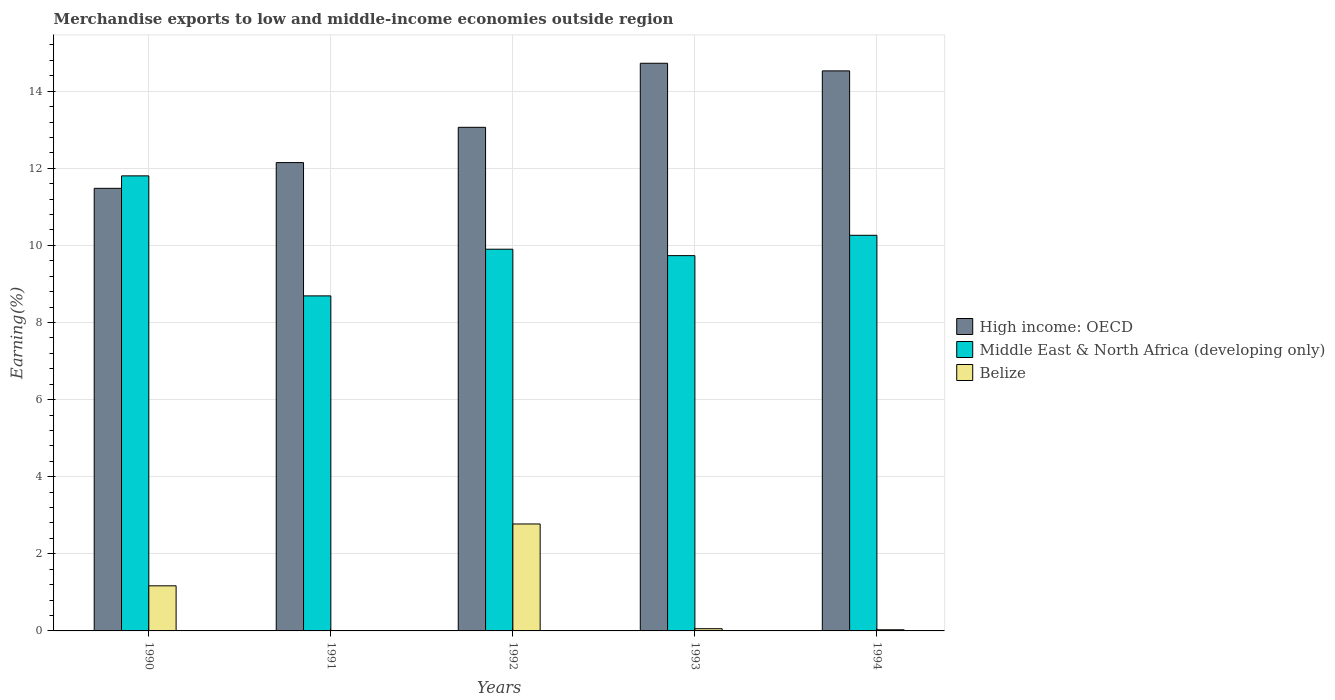How many groups of bars are there?
Your response must be concise. 5. Are the number of bars per tick equal to the number of legend labels?
Provide a short and direct response. Yes. How many bars are there on the 3rd tick from the left?
Offer a very short reply. 3. How many bars are there on the 3rd tick from the right?
Offer a very short reply. 3. What is the label of the 4th group of bars from the left?
Provide a short and direct response. 1993. In how many cases, is the number of bars for a given year not equal to the number of legend labels?
Offer a very short reply. 0. What is the percentage of amount earned from merchandise exports in Belize in 1990?
Your response must be concise. 1.17. Across all years, what is the maximum percentage of amount earned from merchandise exports in Middle East & North Africa (developing only)?
Provide a short and direct response. 11.8. Across all years, what is the minimum percentage of amount earned from merchandise exports in Belize?
Your answer should be very brief. 0. In which year was the percentage of amount earned from merchandise exports in High income: OECD maximum?
Offer a very short reply. 1993. What is the total percentage of amount earned from merchandise exports in High income: OECD in the graph?
Offer a terse response. 65.94. What is the difference between the percentage of amount earned from merchandise exports in Belize in 1990 and that in 1993?
Keep it short and to the point. 1.11. What is the difference between the percentage of amount earned from merchandise exports in Middle East & North Africa (developing only) in 1994 and the percentage of amount earned from merchandise exports in High income: OECD in 1990?
Keep it short and to the point. -1.22. What is the average percentage of amount earned from merchandise exports in Belize per year?
Ensure brevity in your answer.  0.81. In the year 1991, what is the difference between the percentage of amount earned from merchandise exports in Middle East & North Africa (developing only) and percentage of amount earned from merchandise exports in Belize?
Provide a short and direct response. 8.69. In how many years, is the percentage of amount earned from merchandise exports in Middle East & North Africa (developing only) greater than 11.2 %?
Give a very brief answer. 1. What is the ratio of the percentage of amount earned from merchandise exports in Belize in 1990 to that in 1994?
Provide a succinct answer. 39.32. Is the percentage of amount earned from merchandise exports in Belize in 1993 less than that in 1994?
Keep it short and to the point. No. What is the difference between the highest and the second highest percentage of amount earned from merchandise exports in Belize?
Keep it short and to the point. 1.6. What is the difference between the highest and the lowest percentage of amount earned from merchandise exports in Belize?
Give a very brief answer. 2.77. Is the sum of the percentage of amount earned from merchandise exports in Belize in 1990 and 1992 greater than the maximum percentage of amount earned from merchandise exports in High income: OECD across all years?
Offer a very short reply. No. What does the 2nd bar from the left in 1991 represents?
Make the answer very short. Middle East & North Africa (developing only). What does the 2nd bar from the right in 1990 represents?
Give a very brief answer. Middle East & North Africa (developing only). How many years are there in the graph?
Your answer should be compact. 5. Does the graph contain any zero values?
Provide a succinct answer. No. How are the legend labels stacked?
Keep it short and to the point. Vertical. What is the title of the graph?
Offer a very short reply. Merchandise exports to low and middle-income economies outside region. What is the label or title of the X-axis?
Provide a short and direct response. Years. What is the label or title of the Y-axis?
Make the answer very short. Earning(%). What is the Earning(%) of High income: OECD in 1990?
Your response must be concise. 11.48. What is the Earning(%) in Middle East & North Africa (developing only) in 1990?
Your answer should be compact. 11.8. What is the Earning(%) of Belize in 1990?
Give a very brief answer. 1.17. What is the Earning(%) of High income: OECD in 1991?
Your answer should be compact. 12.15. What is the Earning(%) of Middle East & North Africa (developing only) in 1991?
Offer a very short reply. 8.69. What is the Earning(%) of Belize in 1991?
Give a very brief answer. 0. What is the Earning(%) of High income: OECD in 1992?
Provide a short and direct response. 13.06. What is the Earning(%) in Middle East & North Africa (developing only) in 1992?
Provide a succinct answer. 9.9. What is the Earning(%) of Belize in 1992?
Your answer should be compact. 2.77. What is the Earning(%) of High income: OECD in 1993?
Make the answer very short. 14.72. What is the Earning(%) in Middle East & North Africa (developing only) in 1993?
Keep it short and to the point. 9.73. What is the Earning(%) in Belize in 1993?
Offer a very short reply. 0.06. What is the Earning(%) of High income: OECD in 1994?
Keep it short and to the point. 14.53. What is the Earning(%) in Middle East & North Africa (developing only) in 1994?
Your answer should be compact. 10.26. What is the Earning(%) in Belize in 1994?
Your answer should be compact. 0.03. Across all years, what is the maximum Earning(%) in High income: OECD?
Provide a succinct answer. 14.72. Across all years, what is the maximum Earning(%) of Middle East & North Africa (developing only)?
Your response must be concise. 11.8. Across all years, what is the maximum Earning(%) of Belize?
Provide a short and direct response. 2.77. Across all years, what is the minimum Earning(%) of High income: OECD?
Your response must be concise. 11.48. Across all years, what is the minimum Earning(%) in Middle East & North Africa (developing only)?
Your answer should be compact. 8.69. Across all years, what is the minimum Earning(%) in Belize?
Provide a short and direct response. 0. What is the total Earning(%) in High income: OECD in the graph?
Provide a succinct answer. 65.94. What is the total Earning(%) of Middle East & North Africa (developing only) in the graph?
Give a very brief answer. 50.39. What is the total Earning(%) in Belize in the graph?
Offer a terse response. 4.04. What is the difference between the Earning(%) in High income: OECD in 1990 and that in 1991?
Your answer should be compact. -0.67. What is the difference between the Earning(%) of Middle East & North Africa (developing only) in 1990 and that in 1991?
Keep it short and to the point. 3.11. What is the difference between the Earning(%) of Belize in 1990 and that in 1991?
Make the answer very short. 1.17. What is the difference between the Earning(%) of High income: OECD in 1990 and that in 1992?
Offer a terse response. -1.58. What is the difference between the Earning(%) in Middle East & North Africa (developing only) in 1990 and that in 1992?
Ensure brevity in your answer.  1.9. What is the difference between the Earning(%) of Belize in 1990 and that in 1992?
Ensure brevity in your answer.  -1.6. What is the difference between the Earning(%) of High income: OECD in 1990 and that in 1993?
Provide a succinct answer. -3.24. What is the difference between the Earning(%) in Middle East & North Africa (developing only) in 1990 and that in 1993?
Make the answer very short. 2.07. What is the difference between the Earning(%) of Belize in 1990 and that in 1993?
Your answer should be very brief. 1.11. What is the difference between the Earning(%) in High income: OECD in 1990 and that in 1994?
Ensure brevity in your answer.  -3.05. What is the difference between the Earning(%) in Middle East & North Africa (developing only) in 1990 and that in 1994?
Keep it short and to the point. 1.54. What is the difference between the Earning(%) in Belize in 1990 and that in 1994?
Your answer should be compact. 1.14. What is the difference between the Earning(%) in High income: OECD in 1991 and that in 1992?
Keep it short and to the point. -0.91. What is the difference between the Earning(%) of Middle East & North Africa (developing only) in 1991 and that in 1992?
Provide a succinct answer. -1.21. What is the difference between the Earning(%) in Belize in 1991 and that in 1992?
Give a very brief answer. -2.77. What is the difference between the Earning(%) of High income: OECD in 1991 and that in 1993?
Provide a succinct answer. -2.58. What is the difference between the Earning(%) of Middle East & North Africa (developing only) in 1991 and that in 1993?
Ensure brevity in your answer.  -1.04. What is the difference between the Earning(%) in Belize in 1991 and that in 1993?
Make the answer very short. -0.05. What is the difference between the Earning(%) of High income: OECD in 1991 and that in 1994?
Ensure brevity in your answer.  -2.38. What is the difference between the Earning(%) in Middle East & North Africa (developing only) in 1991 and that in 1994?
Your answer should be compact. -1.57. What is the difference between the Earning(%) in Belize in 1991 and that in 1994?
Keep it short and to the point. -0.03. What is the difference between the Earning(%) of High income: OECD in 1992 and that in 1993?
Offer a terse response. -1.66. What is the difference between the Earning(%) in Middle East & North Africa (developing only) in 1992 and that in 1993?
Give a very brief answer. 0.17. What is the difference between the Earning(%) in Belize in 1992 and that in 1993?
Your response must be concise. 2.72. What is the difference between the Earning(%) of High income: OECD in 1992 and that in 1994?
Keep it short and to the point. -1.46. What is the difference between the Earning(%) of Middle East & North Africa (developing only) in 1992 and that in 1994?
Offer a very short reply. -0.36. What is the difference between the Earning(%) in Belize in 1992 and that in 1994?
Offer a very short reply. 2.74. What is the difference between the Earning(%) of High income: OECD in 1993 and that in 1994?
Keep it short and to the point. 0.2. What is the difference between the Earning(%) of Middle East & North Africa (developing only) in 1993 and that in 1994?
Offer a terse response. -0.53. What is the difference between the Earning(%) in Belize in 1993 and that in 1994?
Your response must be concise. 0.03. What is the difference between the Earning(%) of High income: OECD in 1990 and the Earning(%) of Middle East & North Africa (developing only) in 1991?
Give a very brief answer. 2.79. What is the difference between the Earning(%) of High income: OECD in 1990 and the Earning(%) of Belize in 1991?
Keep it short and to the point. 11.48. What is the difference between the Earning(%) of Middle East & North Africa (developing only) in 1990 and the Earning(%) of Belize in 1991?
Make the answer very short. 11.8. What is the difference between the Earning(%) of High income: OECD in 1990 and the Earning(%) of Middle East & North Africa (developing only) in 1992?
Your response must be concise. 1.58. What is the difference between the Earning(%) of High income: OECD in 1990 and the Earning(%) of Belize in 1992?
Provide a succinct answer. 8.71. What is the difference between the Earning(%) of Middle East & North Africa (developing only) in 1990 and the Earning(%) of Belize in 1992?
Give a very brief answer. 9.03. What is the difference between the Earning(%) of High income: OECD in 1990 and the Earning(%) of Middle East & North Africa (developing only) in 1993?
Make the answer very short. 1.75. What is the difference between the Earning(%) in High income: OECD in 1990 and the Earning(%) in Belize in 1993?
Keep it short and to the point. 11.42. What is the difference between the Earning(%) of Middle East & North Africa (developing only) in 1990 and the Earning(%) of Belize in 1993?
Offer a very short reply. 11.75. What is the difference between the Earning(%) of High income: OECD in 1990 and the Earning(%) of Middle East & North Africa (developing only) in 1994?
Your answer should be compact. 1.22. What is the difference between the Earning(%) of High income: OECD in 1990 and the Earning(%) of Belize in 1994?
Your answer should be compact. 11.45. What is the difference between the Earning(%) in Middle East & North Africa (developing only) in 1990 and the Earning(%) in Belize in 1994?
Your answer should be very brief. 11.77. What is the difference between the Earning(%) of High income: OECD in 1991 and the Earning(%) of Middle East & North Africa (developing only) in 1992?
Offer a terse response. 2.25. What is the difference between the Earning(%) in High income: OECD in 1991 and the Earning(%) in Belize in 1992?
Your answer should be compact. 9.37. What is the difference between the Earning(%) of Middle East & North Africa (developing only) in 1991 and the Earning(%) of Belize in 1992?
Offer a very short reply. 5.92. What is the difference between the Earning(%) in High income: OECD in 1991 and the Earning(%) in Middle East & North Africa (developing only) in 1993?
Offer a very short reply. 2.41. What is the difference between the Earning(%) in High income: OECD in 1991 and the Earning(%) in Belize in 1993?
Keep it short and to the point. 12.09. What is the difference between the Earning(%) of Middle East & North Africa (developing only) in 1991 and the Earning(%) of Belize in 1993?
Your answer should be compact. 8.63. What is the difference between the Earning(%) in High income: OECD in 1991 and the Earning(%) in Middle East & North Africa (developing only) in 1994?
Your answer should be very brief. 1.89. What is the difference between the Earning(%) in High income: OECD in 1991 and the Earning(%) in Belize in 1994?
Provide a succinct answer. 12.12. What is the difference between the Earning(%) in Middle East & North Africa (developing only) in 1991 and the Earning(%) in Belize in 1994?
Your answer should be compact. 8.66. What is the difference between the Earning(%) of High income: OECD in 1992 and the Earning(%) of Middle East & North Africa (developing only) in 1993?
Provide a short and direct response. 3.33. What is the difference between the Earning(%) of High income: OECD in 1992 and the Earning(%) of Belize in 1993?
Your answer should be very brief. 13. What is the difference between the Earning(%) of Middle East & North Africa (developing only) in 1992 and the Earning(%) of Belize in 1993?
Keep it short and to the point. 9.84. What is the difference between the Earning(%) in High income: OECD in 1992 and the Earning(%) in Middle East & North Africa (developing only) in 1994?
Offer a terse response. 2.8. What is the difference between the Earning(%) of High income: OECD in 1992 and the Earning(%) of Belize in 1994?
Your response must be concise. 13.03. What is the difference between the Earning(%) of Middle East & North Africa (developing only) in 1992 and the Earning(%) of Belize in 1994?
Ensure brevity in your answer.  9.87. What is the difference between the Earning(%) of High income: OECD in 1993 and the Earning(%) of Middle East & North Africa (developing only) in 1994?
Offer a terse response. 4.46. What is the difference between the Earning(%) in High income: OECD in 1993 and the Earning(%) in Belize in 1994?
Keep it short and to the point. 14.69. What is the difference between the Earning(%) of Middle East & North Africa (developing only) in 1993 and the Earning(%) of Belize in 1994?
Make the answer very short. 9.7. What is the average Earning(%) of High income: OECD per year?
Keep it short and to the point. 13.19. What is the average Earning(%) in Middle East & North Africa (developing only) per year?
Make the answer very short. 10.08. What is the average Earning(%) in Belize per year?
Your answer should be very brief. 0.81. In the year 1990, what is the difference between the Earning(%) of High income: OECD and Earning(%) of Middle East & North Africa (developing only)?
Make the answer very short. -0.32. In the year 1990, what is the difference between the Earning(%) in High income: OECD and Earning(%) in Belize?
Your answer should be very brief. 10.31. In the year 1990, what is the difference between the Earning(%) in Middle East & North Africa (developing only) and Earning(%) in Belize?
Provide a succinct answer. 10.63. In the year 1991, what is the difference between the Earning(%) of High income: OECD and Earning(%) of Middle East & North Africa (developing only)?
Provide a succinct answer. 3.46. In the year 1991, what is the difference between the Earning(%) in High income: OECD and Earning(%) in Belize?
Give a very brief answer. 12.14. In the year 1991, what is the difference between the Earning(%) in Middle East & North Africa (developing only) and Earning(%) in Belize?
Keep it short and to the point. 8.69. In the year 1992, what is the difference between the Earning(%) of High income: OECD and Earning(%) of Middle East & North Africa (developing only)?
Keep it short and to the point. 3.16. In the year 1992, what is the difference between the Earning(%) in High income: OECD and Earning(%) in Belize?
Ensure brevity in your answer.  10.29. In the year 1992, what is the difference between the Earning(%) of Middle East & North Africa (developing only) and Earning(%) of Belize?
Give a very brief answer. 7.13. In the year 1993, what is the difference between the Earning(%) in High income: OECD and Earning(%) in Middle East & North Africa (developing only)?
Your answer should be compact. 4.99. In the year 1993, what is the difference between the Earning(%) in High income: OECD and Earning(%) in Belize?
Your answer should be compact. 14.67. In the year 1993, what is the difference between the Earning(%) in Middle East & North Africa (developing only) and Earning(%) in Belize?
Offer a terse response. 9.68. In the year 1994, what is the difference between the Earning(%) of High income: OECD and Earning(%) of Middle East & North Africa (developing only)?
Your answer should be very brief. 4.26. In the year 1994, what is the difference between the Earning(%) in High income: OECD and Earning(%) in Belize?
Your answer should be compact. 14.5. In the year 1994, what is the difference between the Earning(%) in Middle East & North Africa (developing only) and Earning(%) in Belize?
Give a very brief answer. 10.23. What is the ratio of the Earning(%) in High income: OECD in 1990 to that in 1991?
Make the answer very short. 0.94. What is the ratio of the Earning(%) of Middle East & North Africa (developing only) in 1990 to that in 1991?
Make the answer very short. 1.36. What is the ratio of the Earning(%) in Belize in 1990 to that in 1991?
Offer a very short reply. 267.25. What is the ratio of the Earning(%) of High income: OECD in 1990 to that in 1992?
Provide a short and direct response. 0.88. What is the ratio of the Earning(%) of Middle East & North Africa (developing only) in 1990 to that in 1992?
Give a very brief answer. 1.19. What is the ratio of the Earning(%) of Belize in 1990 to that in 1992?
Your response must be concise. 0.42. What is the ratio of the Earning(%) in High income: OECD in 1990 to that in 1993?
Keep it short and to the point. 0.78. What is the ratio of the Earning(%) of Middle East & North Africa (developing only) in 1990 to that in 1993?
Give a very brief answer. 1.21. What is the ratio of the Earning(%) of Belize in 1990 to that in 1993?
Provide a short and direct response. 20.21. What is the ratio of the Earning(%) in High income: OECD in 1990 to that in 1994?
Your answer should be compact. 0.79. What is the ratio of the Earning(%) of Middle East & North Africa (developing only) in 1990 to that in 1994?
Ensure brevity in your answer.  1.15. What is the ratio of the Earning(%) of Belize in 1990 to that in 1994?
Provide a succinct answer. 39.32. What is the ratio of the Earning(%) of Middle East & North Africa (developing only) in 1991 to that in 1992?
Make the answer very short. 0.88. What is the ratio of the Earning(%) in Belize in 1991 to that in 1992?
Offer a very short reply. 0. What is the ratio of the Earning(%) of High income: OECD in 1991 to that in 1993?
Your response must be concise. 0.82. What is the ratio of the Earning(%) in Middle East & North Africa (developing only) in 1991 to that in 1993?
Offer a very short reply. 0.89. What is the ratio of the Earning(%) of Belize in 1991 to that in 1993?
Your answer should be very brief. 0.08. What is the ratio of the Earning(%) of High income: OECD in 1991 to that in 1994?
Offer a very short reply. 0.84. What is the ratio of the Earning(%) in Middle East & North Africa (developing only) in 1991 to that in 1994?
Your answer should be very brief. 0.85. What is the ratio of the Earning(%) of Belize in 1991 to that in 1994?
Provide a short and direct response. 0.15. What is the ratio of the Earning(%) in High income: OECD in 1992 to that in 1993?
Give a very brief answer. 0.89. What is the ratio of the Earning(%) in Middle East & North Africa (developing only) in 1992 to that in 1993?
Your response must be concise. 1.02. What is the ratio of the Earning(%) in Belize in 1992 to that in 1993?
Provide a succinct answer. 47.91. What is the ratio of the Earning(%) of High income: OECD in 1992 to that in 1994?
Give a very brief answer. 0.9. What is the ratio of the Earning(%) of Middle East & North Africa (developing only) in 1992 to that in 1994?
Give a very brief answer. 0.96. What is the ratio of the Earning(%) in Belize in 1992 to that in 1994?
Your answer should be compact. 93.22. What is the ratio of the Earning(%) in High income: OECD in 1993 to that in 1994?
Keep it short and to the point. 1.01. What is the ratio of the Earning(%) in Middle East & North Africa (developing only) in 1993 to that in 1994?
Your response must be concise. 0.95. What is the ratio of the Earning(%) of Belize in 1993 to that in 1994?
Make the answer very short. 1.95. What is the difference between the highest and the second highest Earning(%) of High income: OECD?
Provide a succinct answer. 0.2. What is the difference between the highest and the second highest Earning(%) in Middle East & North Africa (developing only)?
Give a very brief answer. 1.54. What is the difference between the highest and the second highest Earning(%) in Belize?
Give a very brief answer. 1.6. What is the difference between the highest and the lowest Earning(%) in High income: OECD?
Your answer should be very brief. 3.24. What is the difference between the highest and the lowest Earning(%) of Middle East & North Africa (developing only)?
Keep it short and to the point. 3.11. What is the difference between the highest and the lowest Earning(%) in Belize?
Your answer should be compact. 2.77. 